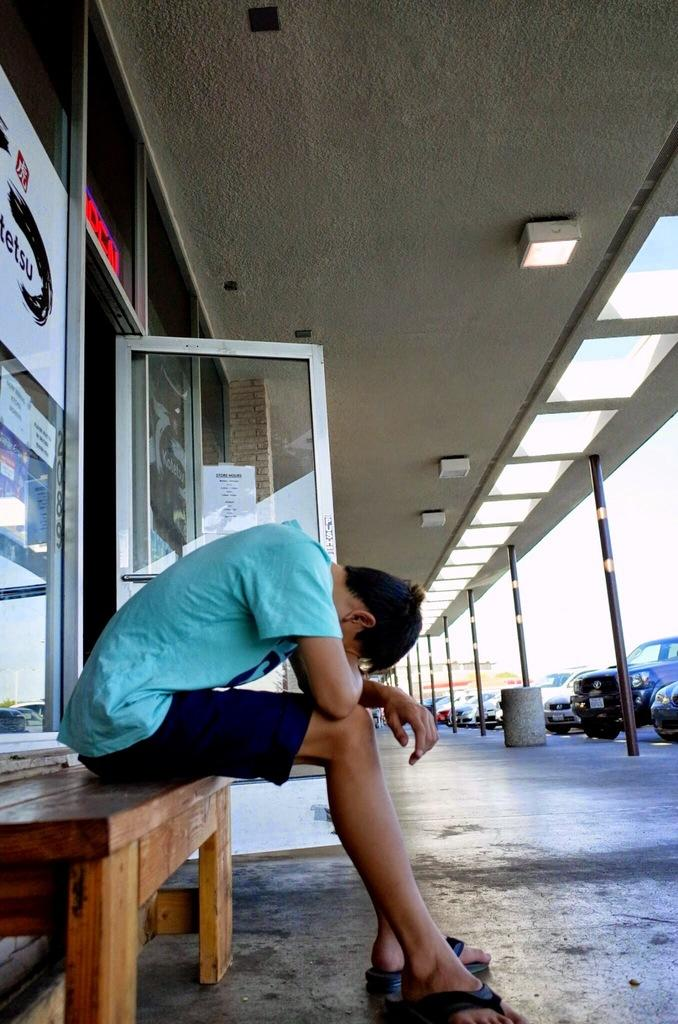What is the person in the image doing? There is a person sitting on a bench in the image. What else can be seen in the image besides the person? Cars and poles are visible in the image. Are there any structures or features on the roof in the image? Yes, there are lights on the roof in the image. What is the size of the mine in the image? There is no mine present in the image. 